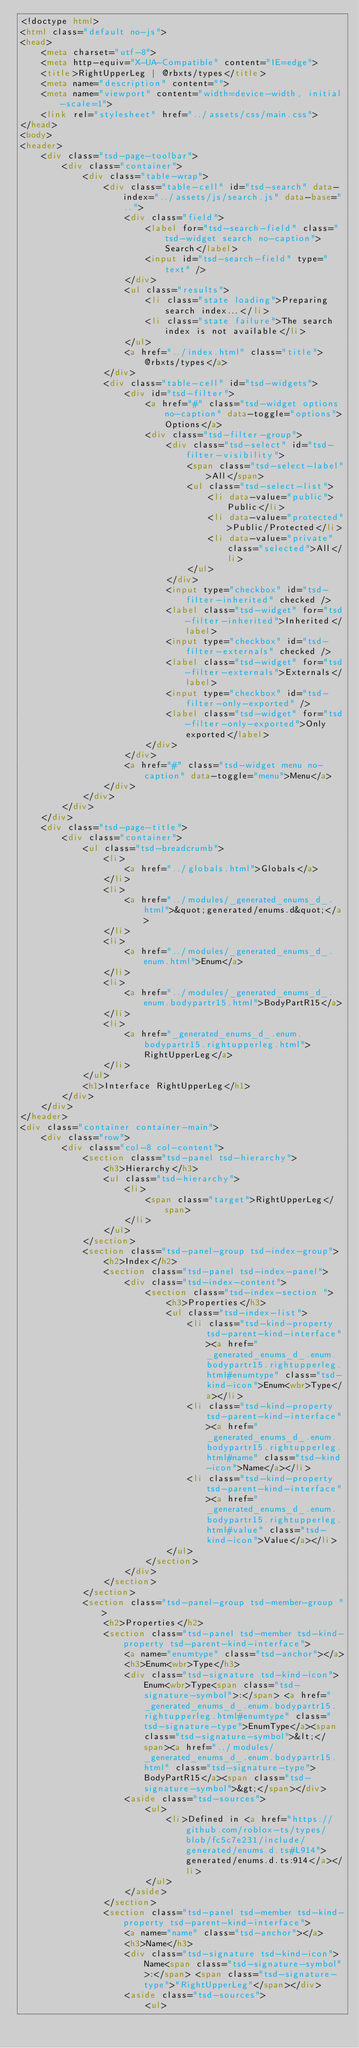Convert code to text. <code><loc_0><loc_0><loc_500><loc_500><_HTML_><!doctype html>
<html class="default no-js">
<head>
	<meta charset="utf-8">
	<meta http-equiv="X-UA-Compatible" content="IE=edge">
	<title>RightUpperLeg | @rbxts/types</title>
	<meta name="description" content="">
	<meta name="viewport" content="width=device-width, initial-scale=1">
	<link rel="stylesheet" href="../assets/css/main.css">
</head>
<body>
<header>
	<div class="tsd-page-toolbar">
		<div class="container">
			<div class="table-wrap">
				<div class="table-cell" id="tsd-search" data-index="../assets/js/search.js" data-base="..">
					<div class="field">
						<label for="tsd-search-field" class="tsd-widget search no-caption">Search</label>
						<input id="tsd-search-field" type="text" />
					</div>
					<ul class="results">
						<li class="state loading">Preparing search index...</li>
						<li class="state failure">The search index is not available</li>
					</ul>
					<a href="../index.html" class="title">@rbxts/types</a>
				</div>
				<div class="table-cell" id="tsd-widgets">
					<div id="tsd-filter">
						<a href="#" class="tsd-widget options no-caption" data-toggle="options">Options</a>
						<div class="tsd-filter-group">
							<div class="tsd-select" id="tsd-filter-visibility">
								<span class="tsd-select-label">All</span>
								<ul class="tsd-select-list">
									<li data-value="public">Public</li>
									<li data-value="protected">Public/Protected</li>
									<li data-value="private" class="selected">All</li>
								</ul>
							</div>
							<input type="checkbox" id="tsd-filter-inherited" checked />
							<label class="tsd-widget" for="tsd-filter-inherited">Inherited</label>
							<input type="checkbox" id="tsd-filter-externals" checked />
							<label class="tsd-widget" for="tsd-filter-externals">Externals</label>
							<input type="checkbox" id="tsd-filter-only-exported" />
							<label class="tsd-widget" for="tsd-filter-only-exported">Only exported</label>
						</div>
					</div>
					<a href="#" class="tsd-widget menu no-caption" data-toggle="menu">Menu</a>
				</div>
			</div>
		</div>
	</div>
	<div class="tsd-page-title">
		<div class="container">
			<ul class="tsd-breadcrumb">
				<li>
					<a href="../globals.html">Globals</a>
				</li>
				<li>
					<a href="../modules/_generated_enums_d_.html">&quot;generated/enums.d&quot;</a>
				</li>
				<li>
					<a href="../modules/_generated_enums_d_.enum.html">Enum</a>
				</li>
				<li>
					<a href="../modules/_generated_enums_d_.enum.bodypartr15.html">BodyPartR15</a>
				</li>
				<li>
					<a href="_generated_enums_d_.enum.bodypartr15.rightupperleg.html">RightUpperLeg</a>
				</li>
			</ul>
			<h1>Interface RightUpperLeg</h1>
		</div>
	</div>
</header>
<div class="container container-main">
	<div class="row">
		<div class="col-8 col-content">
			<section class="tsd-panel tsd-hierarchy">
				<h3>Hierarchy</h3>
				<ul class="tsd-hierarchy">
					<li>
						<span class="target">RightUpperLeg</span>
					</li>
				</ul>
			</section>
			<section class="tsd-panel-group tsd-index-group">
				<h2>Index</h2>
				<section class="tsd-panel tsd-index-panel">
					<div class="tsd-index-content">
						<section class="tsd-index-section ">
							<h3>Properties</h3>
							<ul class="tsd-index-list">
								<li class="tsd-kind-property tsd-parent-kind-interface"><a href="_generated_enums_d_.enum.bodypartr15.rightupperleg.html#enumtype" class="tsd-kind-icon">Enum<wbr>Type</a></li>
								<li class="tsd-kind-property tsd-parent-kind-interface"><a href="_generated_enums_d_.enum.bodypartr15.rightupperleg.html#name" class="tsd-kind-icon">Name</a></li>
								<li class="tsd-kind-property tsd-parent-kind-interface"><a href="_generated_enums_d_.enum.bodypartr15.rightupperleg.html#value" class="tsd-kind-icon">Value</a></li>
							</ul>
						</section>
					</div>
				</section>
			</section>
			<section class="tsd-panel-group tsd-member-group ">
				<h2>Properties</h2>
				<section class="tsd-panel tsd-member tsd-kind-property tsd-parent-kind-interface">
					<a name="enumtype" class="tsd-anchor"></a>
					<h3>Enum<wbr>Type</h3>
					<div class="tsd-signature tsd-kind-icon">Enum<wbr>Type<span class="tsd-signature-symbol">:</span> <a href="_generated_enums_d_.enum.bodypartr15.rightupperleg.html#enumtype" class="tsd-signature-type">EnumType</a><span class="tsd-signature-symbol">&lt;</span><a href="../modules/_generated_enums_d_.enum.bodypartr15.html" class="tsd-signature-type">BodyPartR15</a><span class="tsd-signature-symbol">&gt;</span></div>
					<aside class="tsd-sources">
						<ul>
							<li>Defined in <a href="https://github.com/roblox-ts/types/blob/fc5c7e231/include/generated/enums.d.ts#L914">generated/enums.d.ts:914</a></li>
						</ul>
					</aside>
				</section>
				<section class="tsd-panel tsd-member tsd-kind-property tsd-parent-kind-interface">
					<a name="name" class="tsd-anchor"></a>
					<h3>Name</h3>
					<div class="tsd-signature tsd-kind-icon">Name<span class="tsd-signature-symbol">:</span> <span class="tsd-signature-type">"RightUpperLeg"</span></div>
					<aside class="tsd-sources">
						<ul></code> 